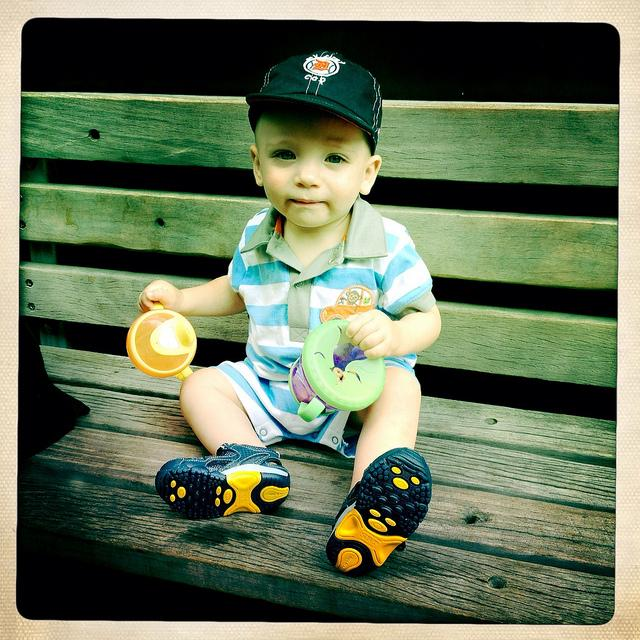What book series does he probably like?

Choices:
A) berenstain bears
B) amelia bedelia
C) clifford
D) curious george curious george 